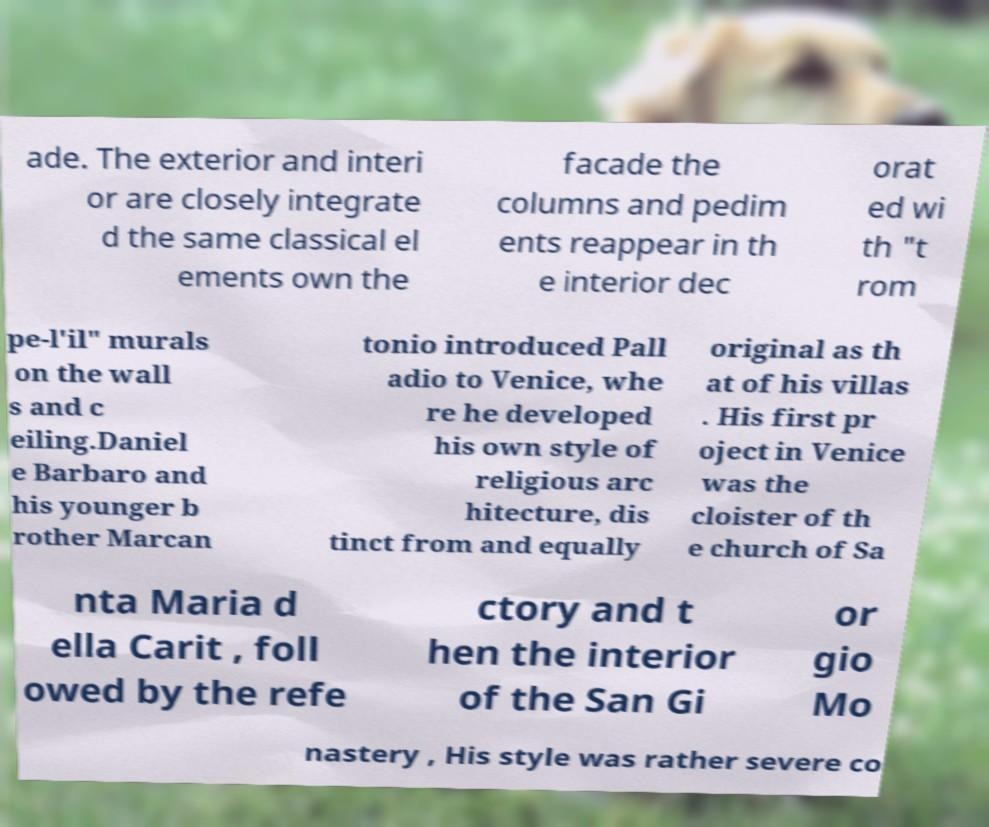Please read and relay the text visible in this image. What does it say? ade. The exterior and interi or are closely integrate d the same classical el ements own the facade the columns and pedim ents reappear in th e interior dec orat ed wi th "t rom pe-l'il" murals on the wall s and c eiling.Daniel e Barbaro and his younger b rother Marcan tonio introduced Pall adio to Venice, whe re he developed his own style of religious arc hitecture, dis tinct from and equally original as th at of his villas . His first pr oject in Venice was the cloister of th e church of Sa nta Maria d ella Carit , foll owed by the refe ctory and t hen the interior of the San Gi or gio Mo nastery , His style was rather severe co 